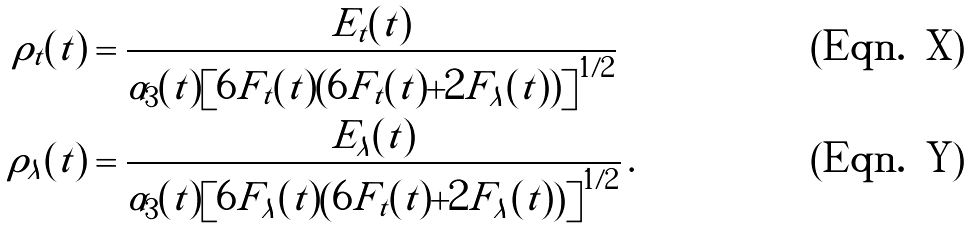Convert formula to latex. <formula><loc_0><loc_0><loc_500><loc_500>\rho _ { t } ( t ) & = \frac { E _ { t } ( t ) } { \tilde { \alpha } _ { 3 } ( t ) \left [ 6 F _ { t } ( t ) ( 6 F _ { t } ( t ) + 2 F _ { \lambda } ( t ) ) \right ] ^ { 1 / 2 } } \\ \rho _ { \lambda } ( t ) & = \frac { E _ { \lambda } ( t ) } { \tilde { \alpha } _ { 3 } ( t ) \left [ 6 F _ { \lambda } ( t ) \left ( 6 F _ { t } ( t ) + 2 F _ { \lambda } ( t ) \right ) \right ] ^ { 1 / 2 } } \, .</formula> 